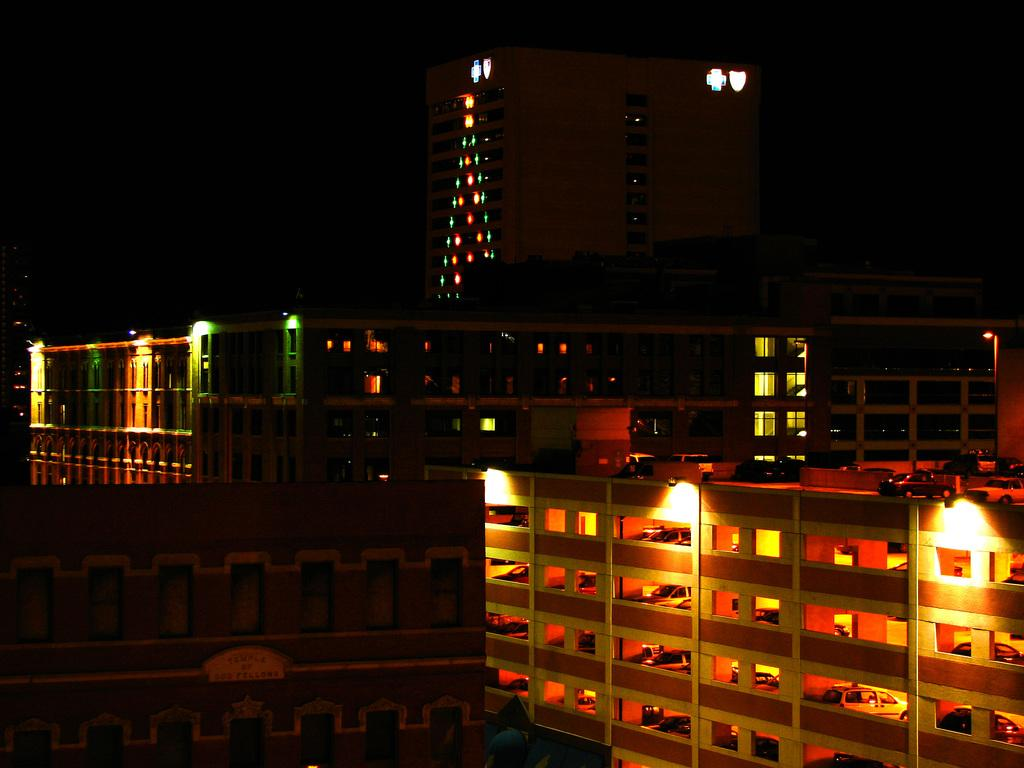What type of structures can be seen in the image? There are buildings in the image. What else is present in the image besides buildings? There are vehicles and lights visible in the image. How many balls are being used to play a game in the image? There are no balls present in the image. What type of sail can be seen on a boat in the image? There is no boat or sail present in the image. 